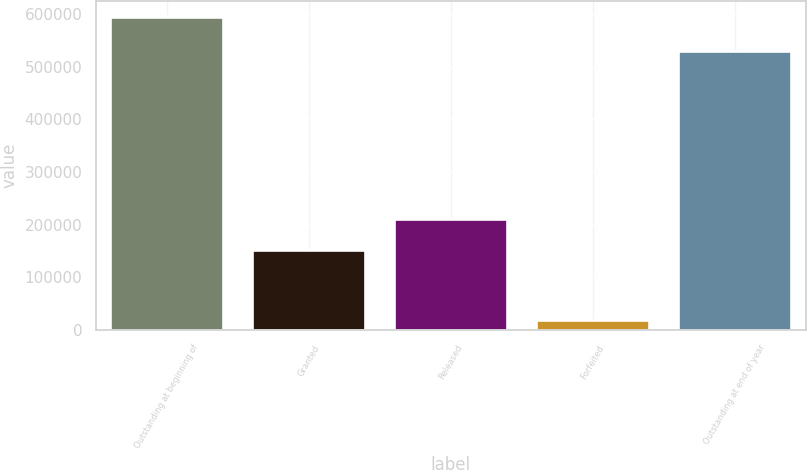Convert chart to OTSL. <chart><loc_0><loc_0><loc_500><loc_500><bar_chart><fcel>Outstanding at beginning of<fcel>Granted<fcel>Released<fcel>Forfeited<fcel>Outstanding at end of year<nl><fcel>594090<fcel>152636<fcel>210108<fcel>19374<fcel>529880<nl></chart> 